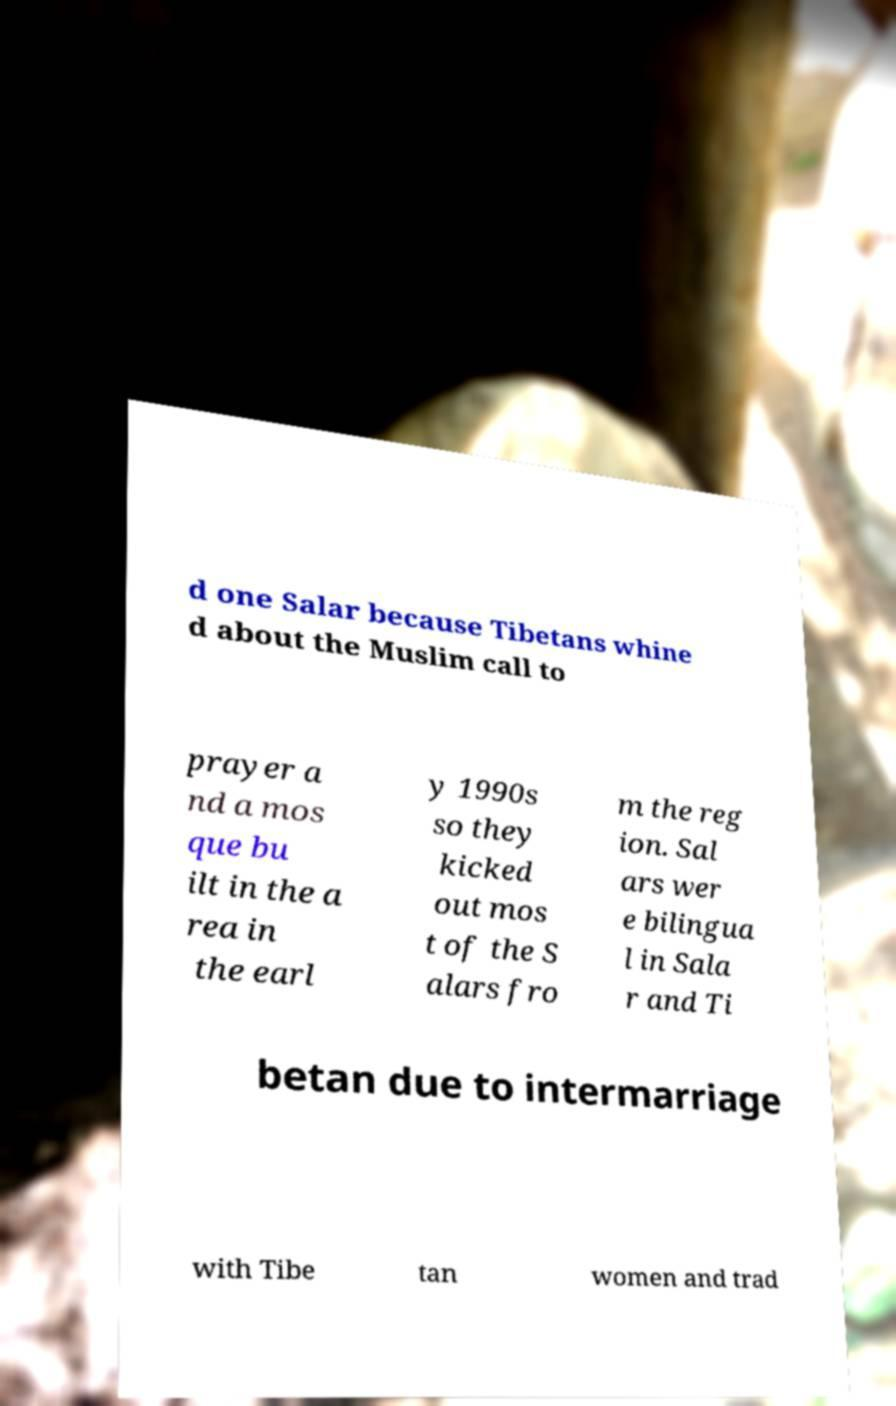I need the written content from this picture converted into text. Can you do that? d one Salar because Tibetans whine d about the Muslim call to prayer a nd a mos que bu ilt in the a rea in the earl y 1990s so they kicked out mos t of the S alars fro m the reg ion. Sal ars wer e bilingua l in Sala r and Ti betan due to intermarriage with Tibe tan women and trad 